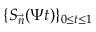<formula> <loc_0><loc_0><loc_500><loc_500>\{ S _ { \vec { n } } ( \Psi t ) \} _ { 0 \leq t \leq 1 }</formula> 